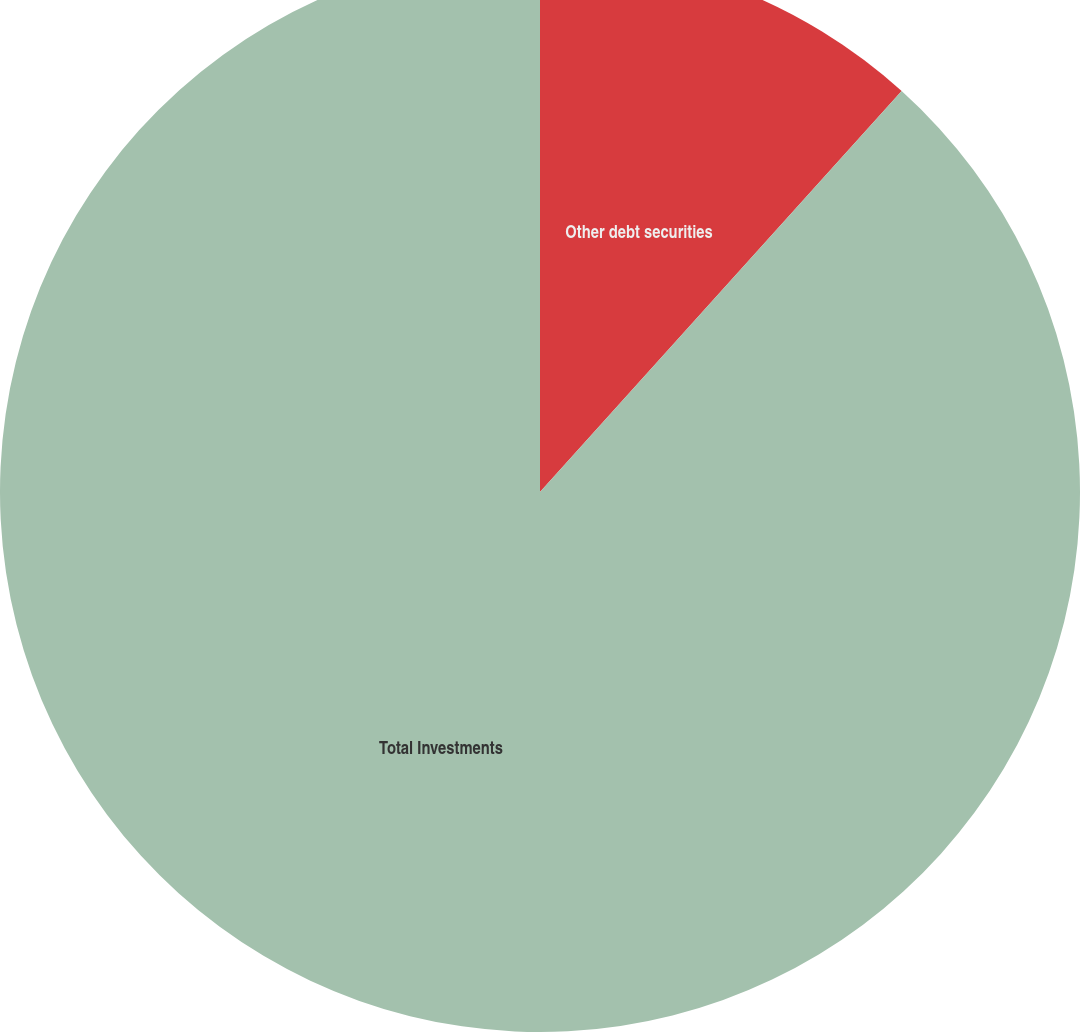Convert chart. <chart><loc_0><loc_0><loc_500><loc_500><pie_chart><fcel>Other debt securities<fcel>Total Investments<nl><fcel>11.68%<fcel>88.32%<nl></chart> 